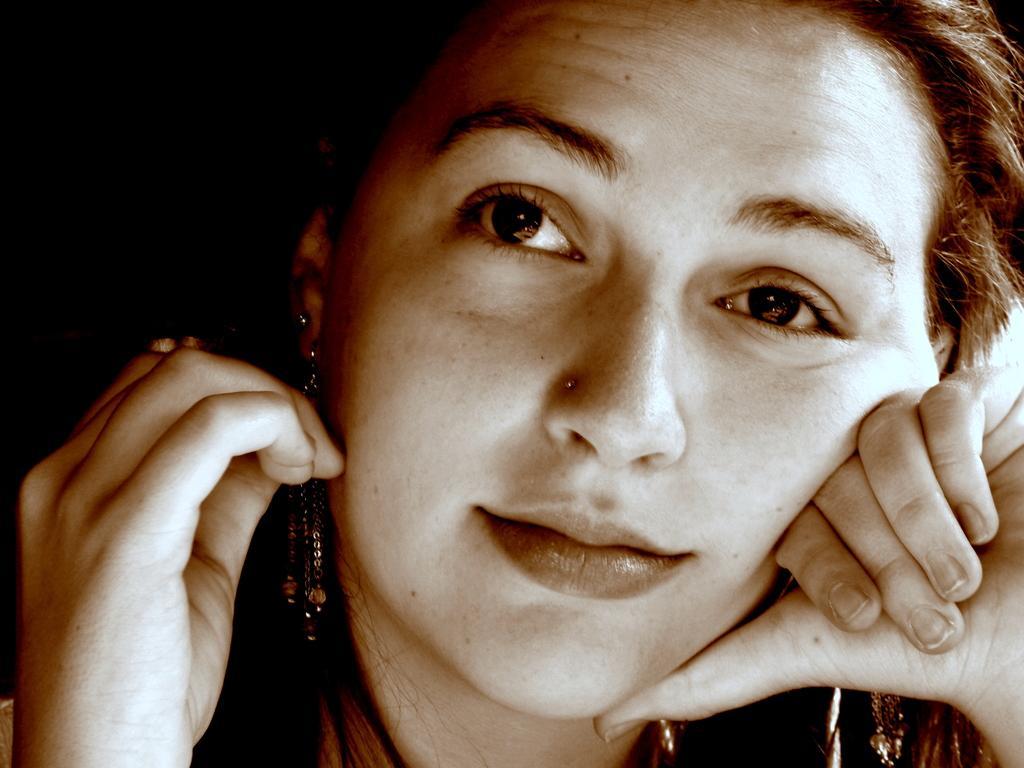Describe this image in one or two sentences. In this picture I can see a woman in front and I see that it is dark on the top left of this image. 